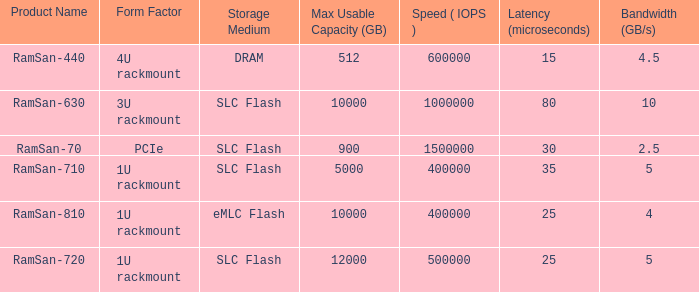What is the distortion in shape for a frequency range of 10? 3U rackmount. 